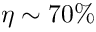Convert formula to latex. <formula><loc_0><loc_0><loc_500><loc_500>\eta \sim 7 0 \%</formula> 